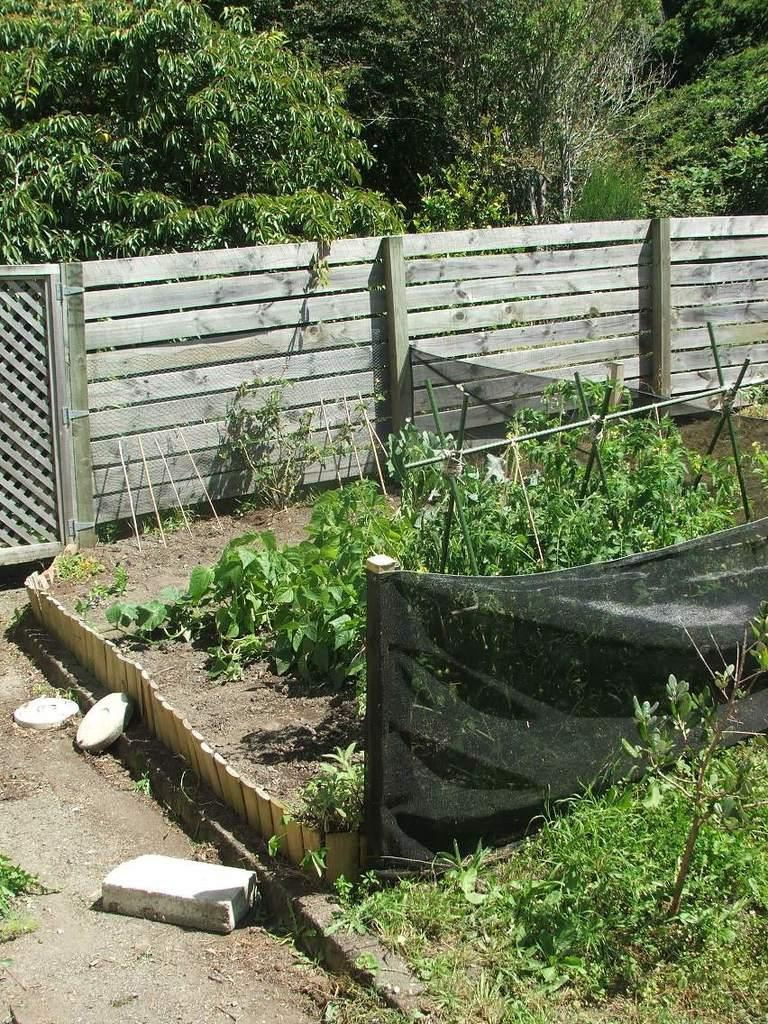What type of structure can be seen in the image? There is a fence in the image. What other elements are present in the image? There are plants in the image. What can be seen in the background of the image? There are trees visible in the background of the image. How many boys are playing the guitar in the image? There are no boys or guitars present in the image. Can you see any ants crawling on the fence in the image? There are no ants visible in the image. 